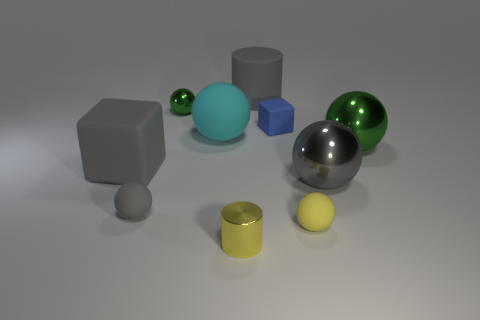What number of metal objects are either tiny yellow cylinders or large gray things?
Offer a very short reply. 2. The small green shiny object has what shape?
Give a very brief answer. Sphere. What is the material of the block that is the same size as the matte cylinder?
Your answer should be compact. Rubber. What number of tiny things are gray things or matte objects?
Your response must be concise. 3. Is there a large red object?
Provide a succinct answer. No. There is a gray ball that is made of the same material as the tiny yellow cylinder; what is its size?
Make the answer very short. Large. Are the big cyan object and the yellow ball made of the same material?
Your answer should be very brief. Yes. How many other things are there of the same material as the tiny blue block?
Keep it short and to the point. 5. How many things are left of the large gray metallic ball and on the right side of the large gray cube?
Make the answer very short. 7. What is the color of the small cube?
Your answer should be compact. Blue. 